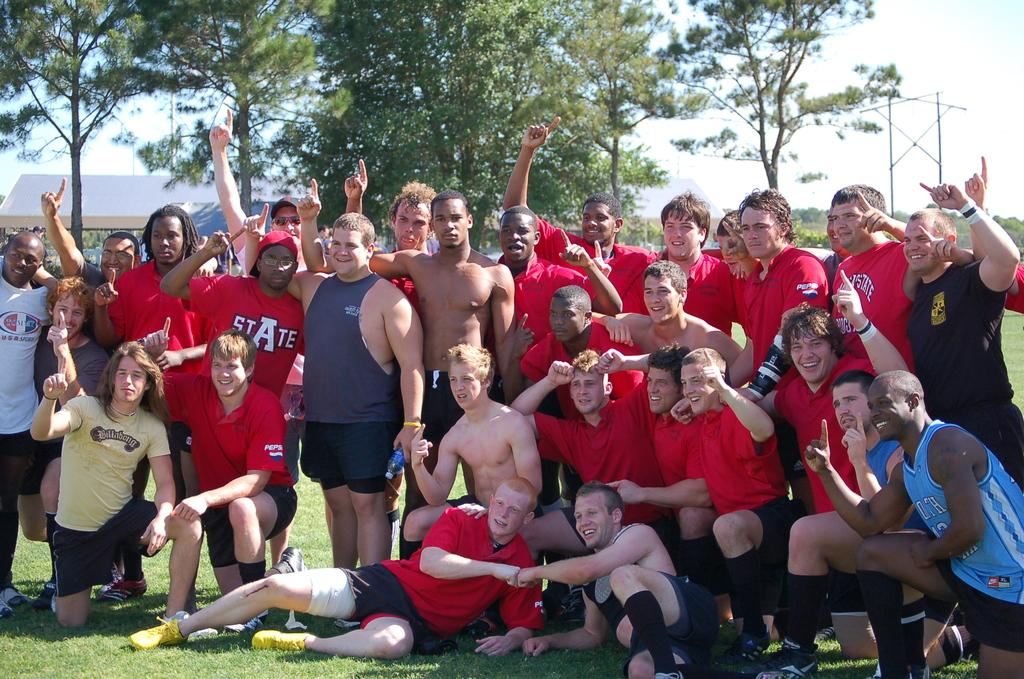How many people are in the image? There is a group of people in the image, but the exact number cannot be determined from the provided facts. What are the people in the image doing? The people are on the ground, but their specific activity is not mentioned in the facts. What can be seen in the background of the image? There are tents, trees, a metal rod, and the sky visible in the background of the image. Can you describe the time of day when the image was taken? The image was likely taken during the day, as the sky is visible and there is no mention of darkness or artificial lighting. What type of jam is being spread on the cats in the image? There are no cats or jam present in the image; it features a group of people on the ground with tents, trees, a metal rod, and the sky visible in the background. 